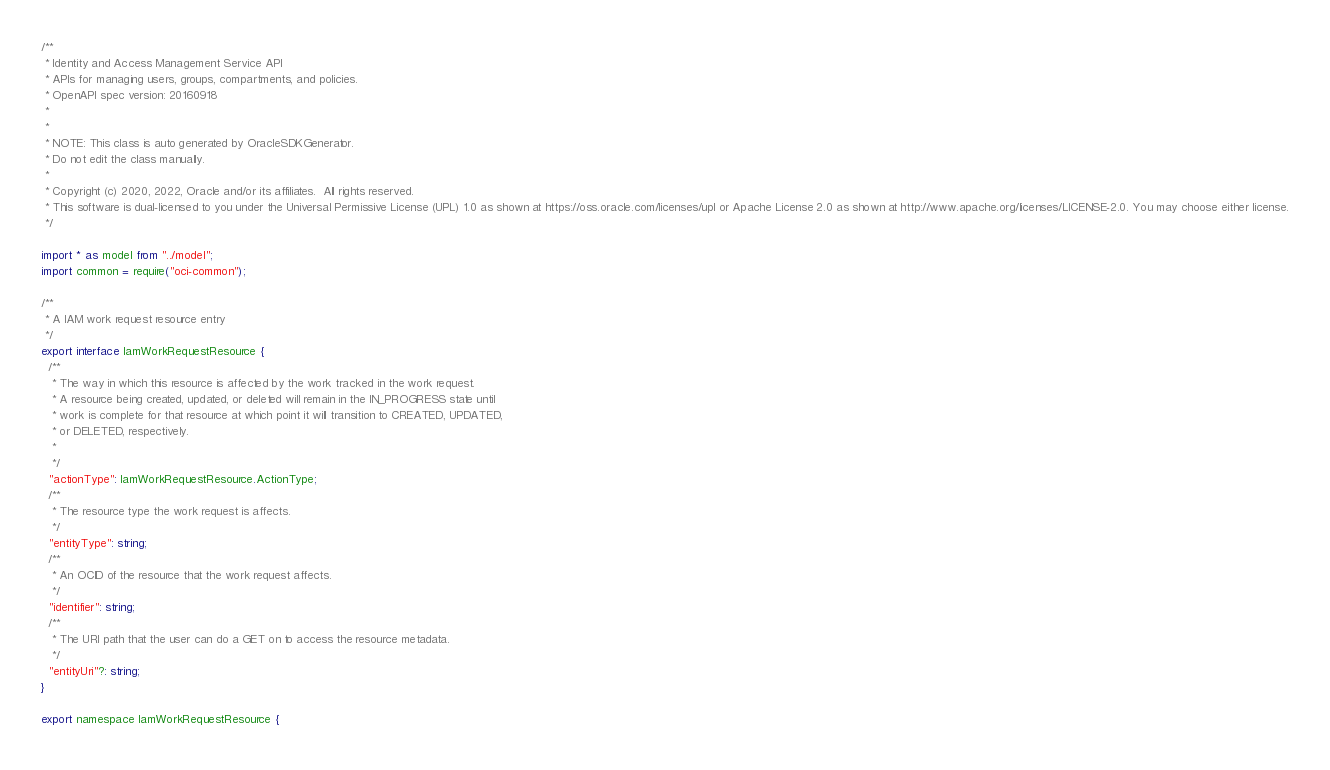<code> <loc_0><loc_0><loc_500><loc_500><_TypeScript_>/**
 * Identity and Access Management Service API
 * APIs for managing users, groups, compartments, and policies.
 * OpenAPI spec version: 20160918
 *
 *
 * NOTE: This class is auto generated by OracleSDKGenerator.
 * Do not edit the class manually.
 *
 * Copyright (c) 2020, 2022, Oracle and/or its affiliates.  All rights reserved.
 * This software is dual-licensed to you under the Universal Permissive License (UPL) 1.0 as shown at https://oss.oracle.com/licenses/upl or Apache License 2.0 as shown at http://www.apache.org/licenses/LICENSE-2.0. You may choose either license.
 */

import * as model from "../model";
import common = require("oci-common");

/**
 * A IAM work request resource entry
 */
export interface IamWorkRequestResource {
  /**
   * The way in which this resource is affected by the work tracked in the work request.
   * A resource being created, updated, or deleted will remain in the IN_PROGRESS state until
   * work is complete for that resource at which point it will transition to CREATED, UPDATED,
   * or DELETED, respectively.
   *
   */
  "actionType": IamWorkRequestResource.ActionType;
  /**
   * The resource type the work request is affects.
   */
  "entityType": string;
  /**
   * An OCID of the resource that the work request affects.
   */
  "identifier": string;
  /**
   * The URI path that the user can do a GET on to access the resource metadata.
   */
  "entityUri"?: string;
}

export namespace IamWorkRequestResource {</code> 